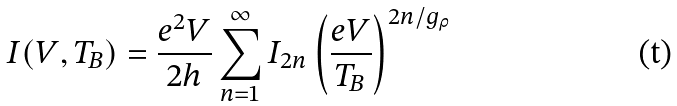Convert formula to latex. <formula><loc_0><loc_0><loc_500><loc_500>I ( V , T _ { B } ) = \frac { e ^ { 2 } V } { 2 h } \sum _ { n = 1 } ^ { \infty } I _ { 2 n } \left ( \frac { e V } { T _ { B } } \right ) ^ { 2 n / g _ { \rho } }</formula> 